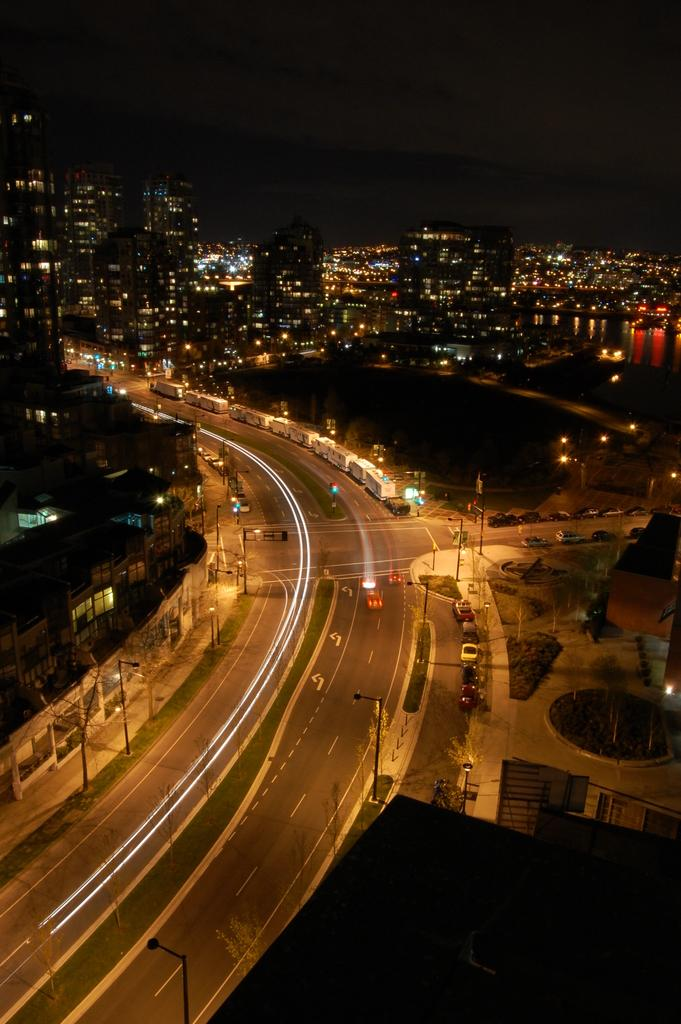What type of structures can be seen in the image? There are buildings in the image. What else is present in the image besides buildings? There are vehicles and poles in the image. Are there any illumination sources visible in the image? Yes, there are lights in the image. How many people are sleeping in the image? There is no indication of anyone sleeping in the image. The image primarily features buildings, vehicles, poles, and lights. 